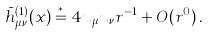Convert formula to latex. <formula><loc_0><loc_0><loc_500><loc_500>\bar { h } ^ { ( 1 ) } _ { \mu \nu } ( x ) \stackrel { * } = 4 u _ { \mu } u _ { \nu } r ^ { - 1 } + O ( r ^ { 0 } ) \, .</formula> 